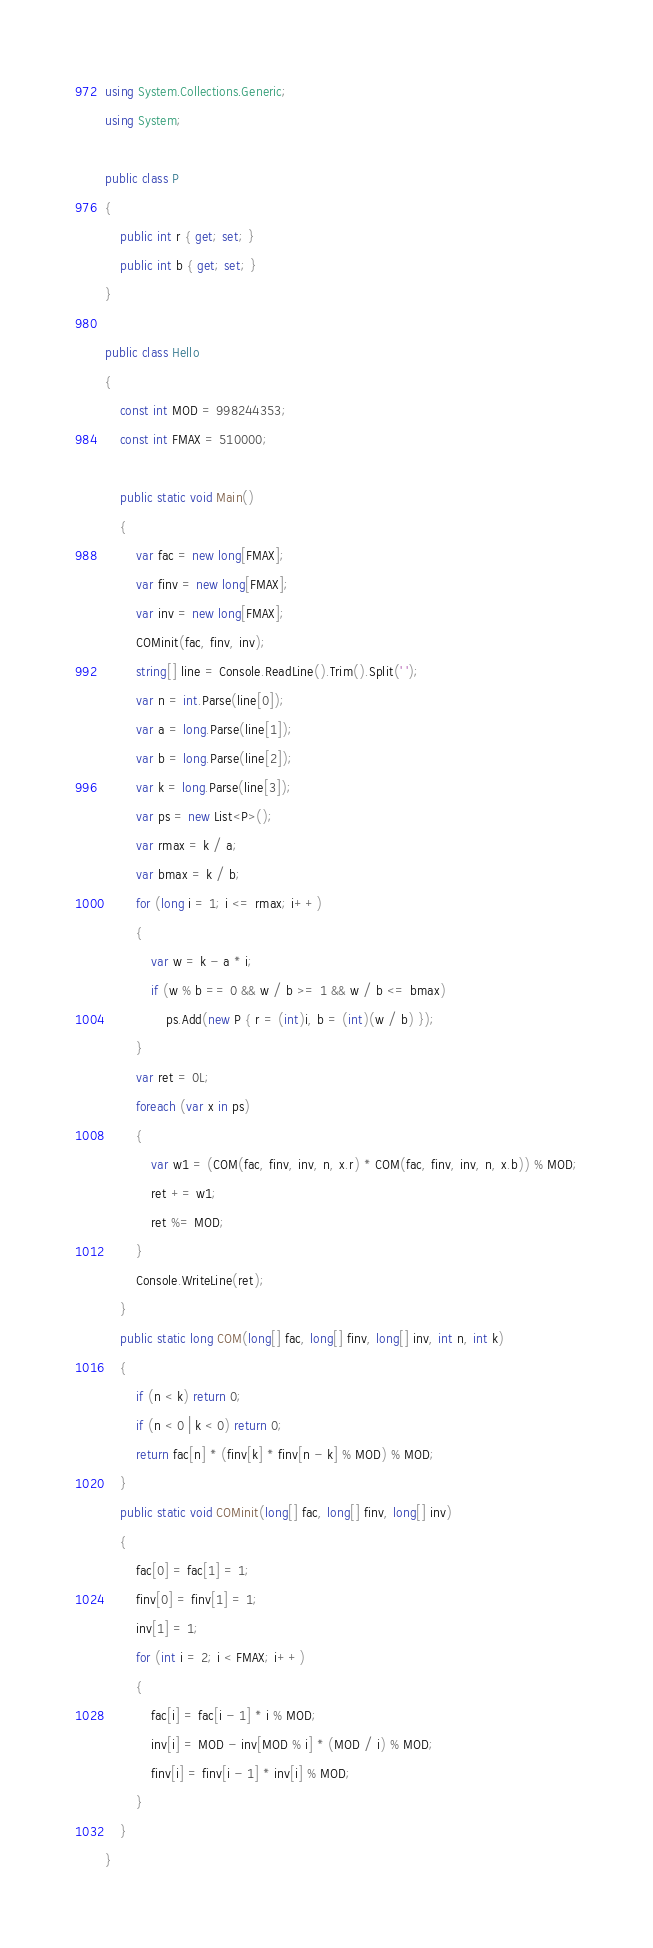Convert code to text. <code><loc_0><loc_0><loc_500><loc_500><_C#_>using System.Collections.Generic;
using System;

public class P
{
    public int r { get; set; }
    public int b { get; set; }
}

public class Hello
{
    const int MOD = 998244353;
    const int FMAX = 510000;

    public static void Main()
    {
        var fac = new long[FMAX];
        var finv = new long[FMAX];
        var inv = new long[FMAX];
        COMinit(fac, finv, inv);
        string[] line = Console.ReadLine().Trim().Split(' ');
        var n = int.Parse(line[0]);
        var a = long.Parse(line[1]);
        var b = long.Parse(line[2]);
        var k = long.Parse(line[3]);
        var ps = new List<P>();
        var rmax = k / a;
        var bmax = k / b;
        for (long i = 1; i <= rmax; i++)
        {
            var w = k - a * i;
            if (w % b == 0 && w / b >= 1 && w / b <= bmax)
                ps.Add(new P { r = (int)i, b = (int)(w / b) });
        }
        var ret = 0L;
        foreach (var x in ps)
        {
            var w1 = (COM(fac, finv, inv, n, x.r) * COM(fac, finv, inv, n, x.b)) % MOD;
            ret += w1;
            ret %= MOD;
        }
        Console.WriteLine(ret);
    }
    public static long COM(long[] fac, long[] finv, long[] inv, int n, int k)
    {
        if (n < k) return 0;
        if (n < 0 | k < 0) return 0;
        return fac[n] * (finv[k] * finv[n - k] % MOD) % MOD;
    }
    public static void COMinit(long[] fac, long[] finv, long[] inv)
    {
        fac[0] = fac[1] = 1;
        finv[0] = finv[1] = 1;
        inv[1] = 1;
        for (int i = 2; i < FMAX; i++)
        {
            fac[i] = fac[i - 1] * i % MOD;
            inv[i] = MOD - inv[MOD % i] * (MOD / i) % MOD;
            finv[i] = finv[i - 1] * inv[i] % MOD;
        }
    }
}
</code> 